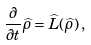<formula> <loc_0><loc_0><loc_500><loc_500>\frac { \partial } { \partial t } \widehat { \rho } = \widehat { L } ( \widehat { \rho } ) \, ,</formula> 